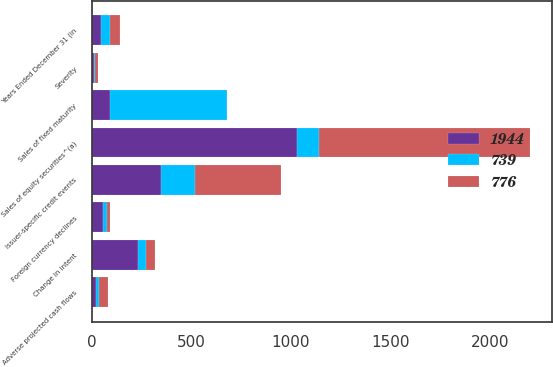<chart> <loc_0><loc_0><loc_500><loc_500><stacked_bar_chart><ecel><fcel>Years Ended December 31 (in<fcel>Sales of fixed maturity<fcel>Sales of equity securities^(a)<fcel>Severity<fcel>Change in intent<fcel>Foreign currency declines<fcel>Issuer-specific credit events<fcel>Adverse projected cash flows<nl><fcel>776<fcel>47<fcel>1<fcel>1057<fcel>15<fcel>46<fcel>18<fcel>433<fcel>47<nl><fcel>1944<fcel>47<fcel>94<fcel>1032<fcel>13<fcel>233<fcel>57<fcel>348<fcel>20<nl><fcel>739<fcel>47<fcel>585<fcel>111<fcel>3<fcel>40<fcel>19<fcel>169<fcel>16<nl></chart> 